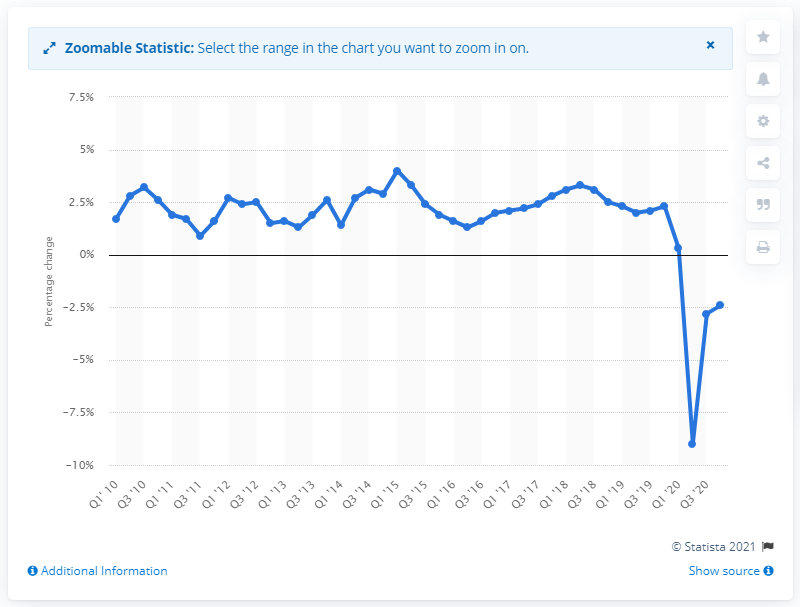Point out several critical features in this image. The Gross Domestic Product (GDP) of the United States in the fourth quarter of 2020 was 2.4 trillion dollars. 